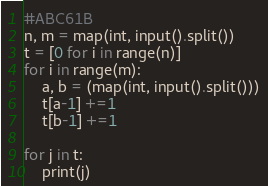<code> <loc_0><loc_0><loc_500><loc_500><_Python_>#ABC61B
n, m = map(int, input().split())
t = [0 for i in range(n)]
for i in range(m):
    a, b = (map(int, input().split()))
    t[a-1] +=1
    t[b-1] +=1
    
for j in t:
    print(j)</code> 